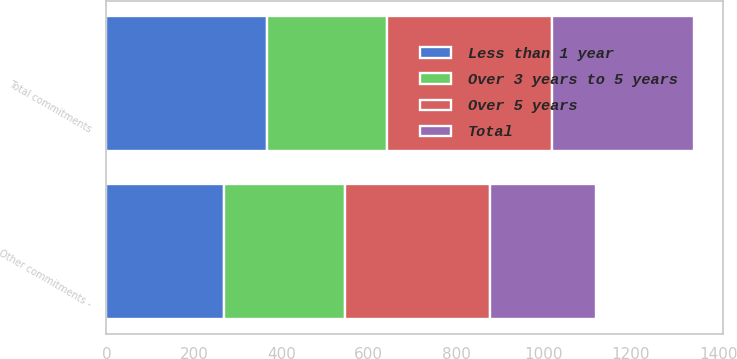Convert chart to OTSL. <chart><loc_0><loc_0><loc_500><loc_500><stacked_bar_chart><ecel><fcel>Other commitments -<fcel>Total commitments<nl><fcel>Over 3 years to 5 years<fcel>275<fcel>275<nl><fcel>Total<fcel>243<fcel>324<nl><fcel>Less than 1 year<fcel>270<fcel>367<nl><fcel>Over 5 years<fcel>333<fcel>378<nl></chart> 